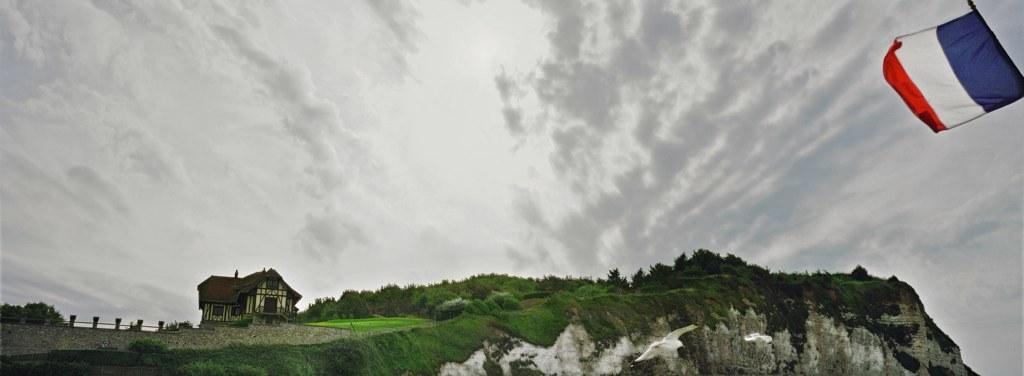In one or two sentences, can you explain what this image depicts? In the image we can see a building, grass, trees, fence, the flag of a country, mountain, big stone and a cloudy sky. 